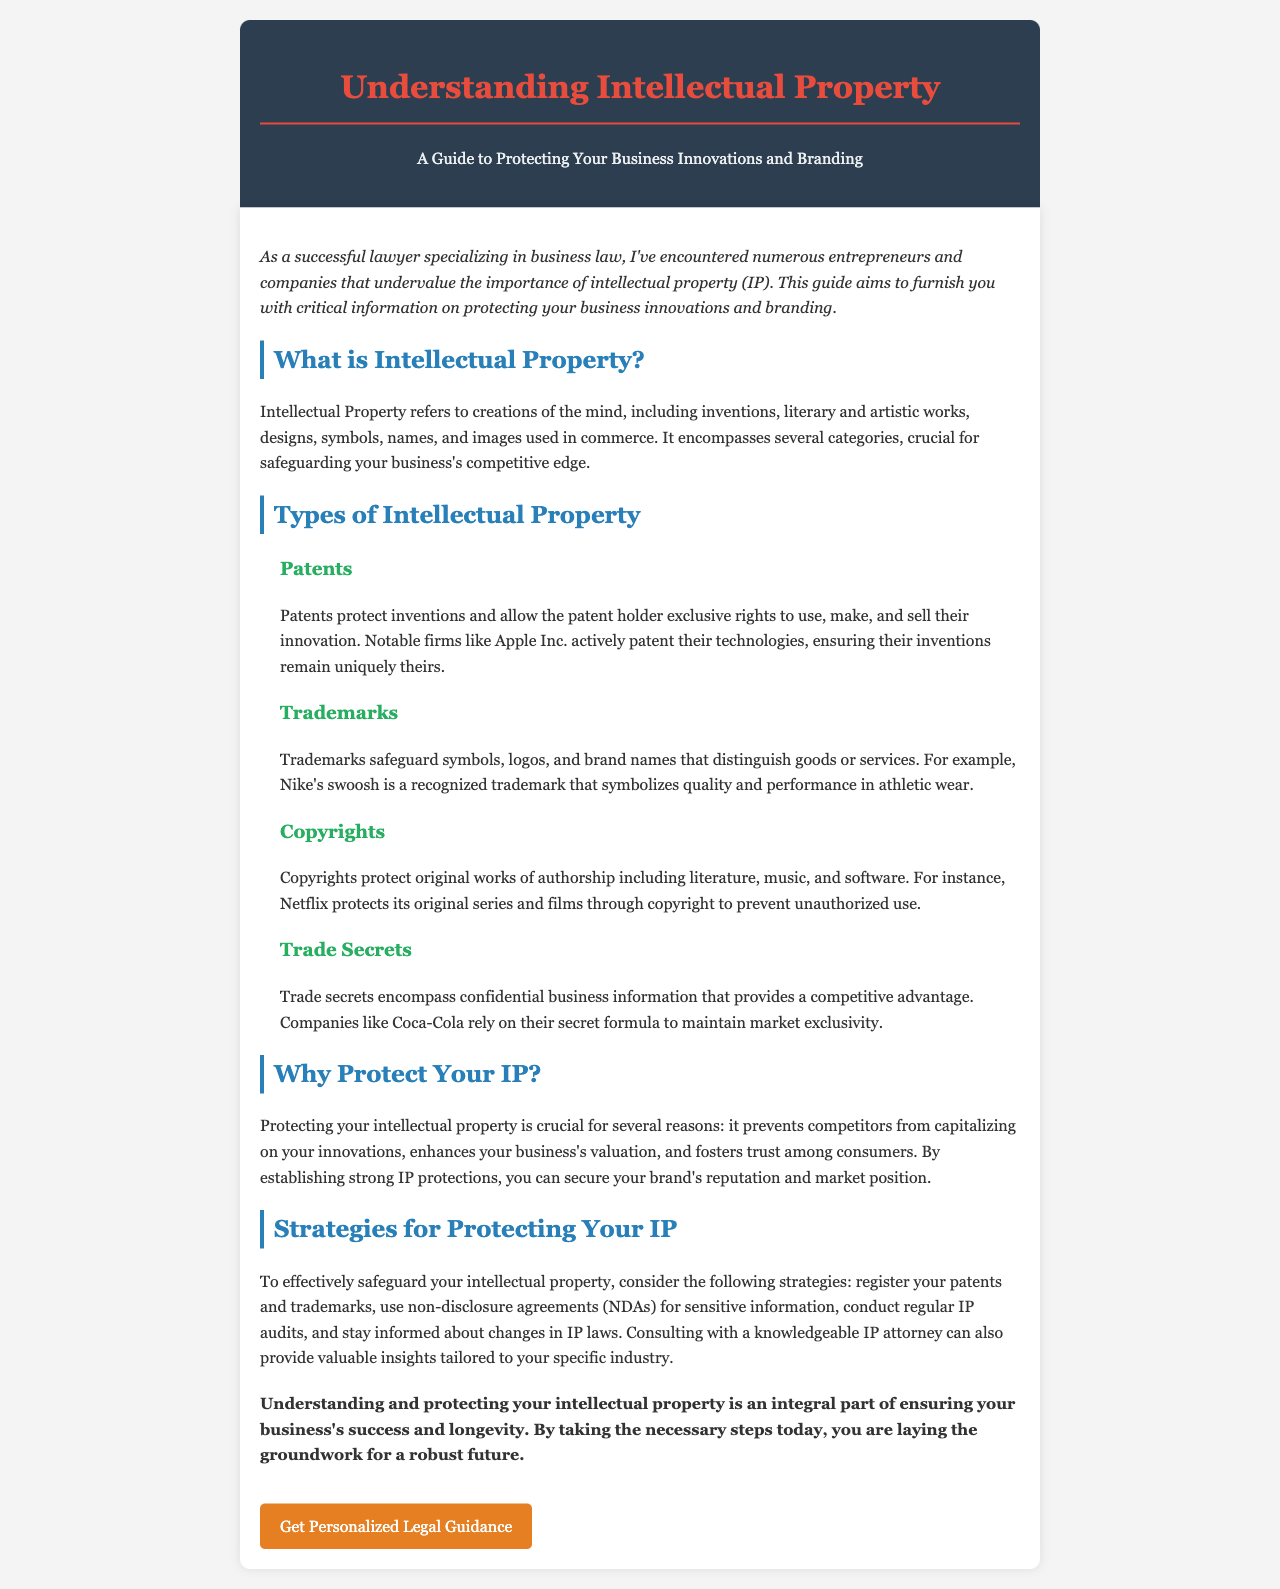What is Intellectual Property? Intellectual Property refers to creations of the mind, including inventions, literary and artistic works, designs, symbols, names, and images used in commerce.
Answer: Creations of the mind What are the types of Intellectual Property listed? The document outlines four specific types of Intellectual Property.
Answer: Patents, Trademarks, Copyrights, Trade Secrets What company is mentioned as actively patenting its technologies? The document mentions a notable firm that patents its technologies to protect its innovations.
Answer: Apple Inc Why is protecting your IP important? The document lists reasons for protecting intellectual property, which includes preventing competitors from capitalizing on innovations.
Answer: Prevents competitors What is a strategy for protecting your IP? The document suggests several strategies for safeguarding intellectual property, asking for just one.
Answer: Register your patents and trademarks What does the acronym NDA stand for? The document refers to a certain type of agreement that protects sensitive information by a specific acronym.
Answer: Non-disclosure agreement What color is used for the document title? The title of the newsletter is emphasized in a specific color in the document.
Answer: Red What is the call to action in the document? The last section of the document includes a specific directive for the reader.
Answer: Get Personalized Legal Guidance 